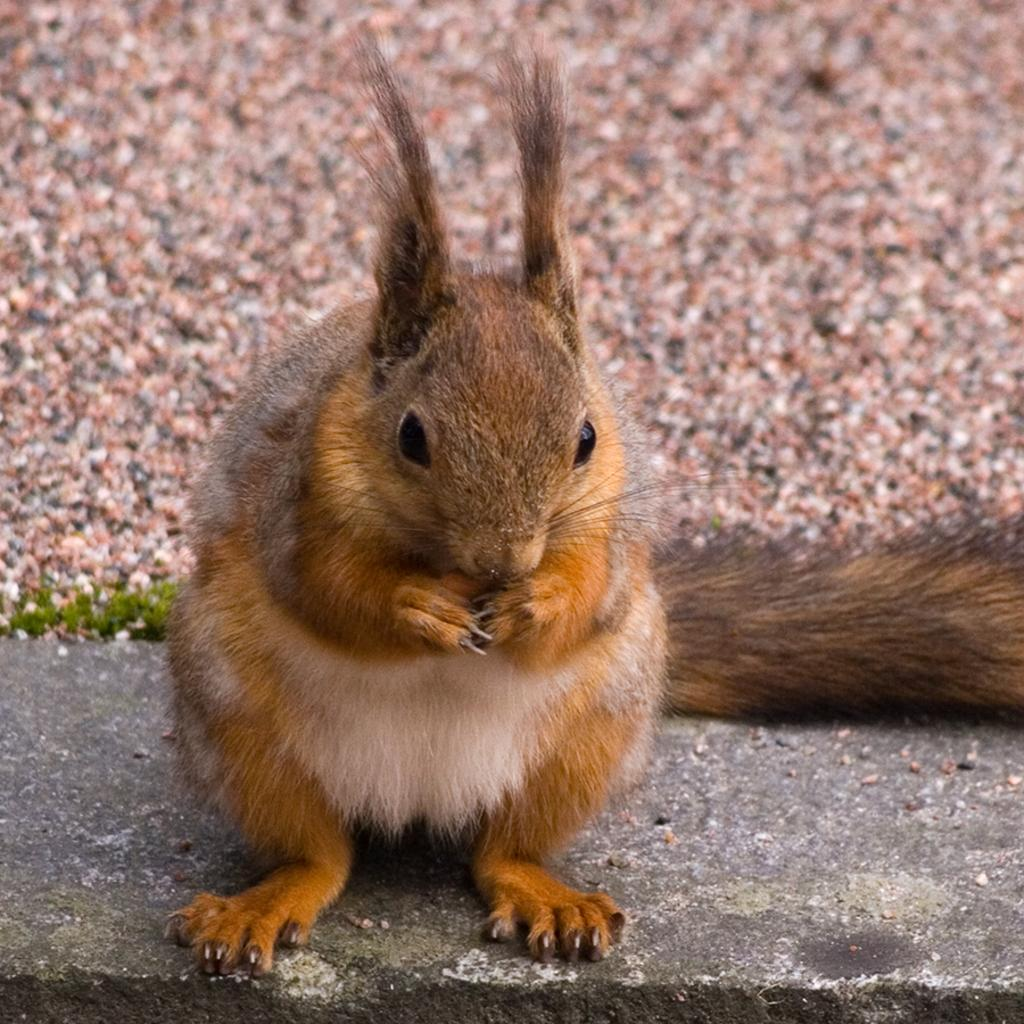What type of animal is in the image? There is a squirrel in the image. Where is the squirrel located? The squirrel is on the wall. What type of haircut does the squirrel have in the image? There is no mention of a haircut in the image, as it features a squirrel on the wall. 